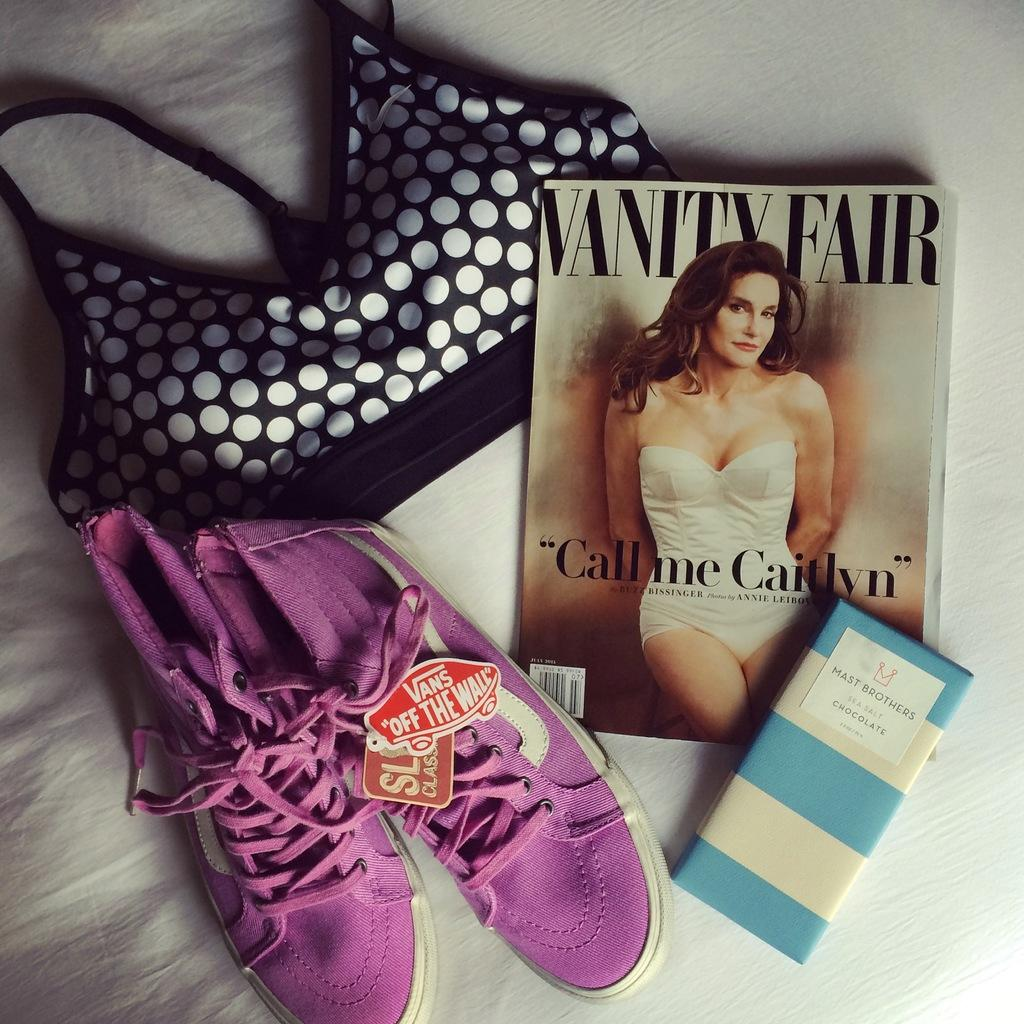What objects are placed on the white surface in the image? There are shoes, a book, chocolate, and cloth on the white surface. Can you describe the color of the shoes? The color of the shoes is not mentioned in the facts, so we cannot determine their color from the image. What type of chocolate is on the white surface? The type of chocolate is not specified in the facts, so we cannot determine its type from the image. What might the cloth be used for? The purpose of the cloth is not mentioned in the facts, so we cannot determine its intended use from the image. What type of produce can be seen growing on the white surface? There is no produce visible on the white surface in the image. 